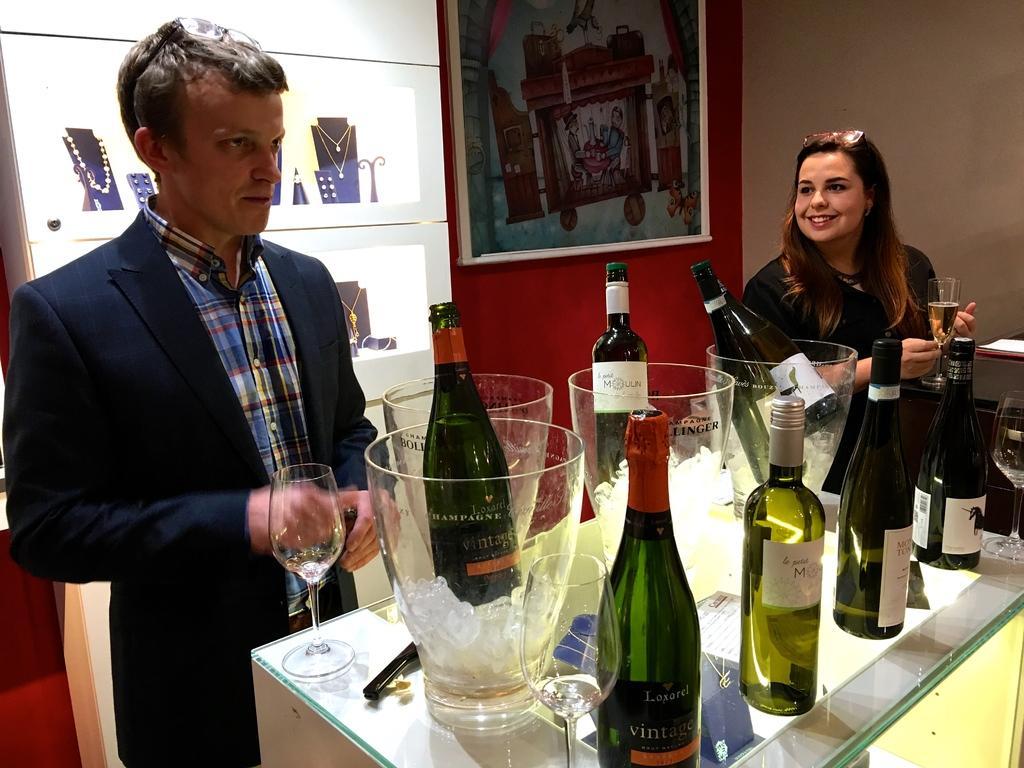How would you summarize this image in a sentence or two? In this picture we can see man and woman standing and smiling and in front of them there is table and on table we can see bottles, glasses, ice cubes in jar and in background we can see frame, showcase with jewelry, wall. 